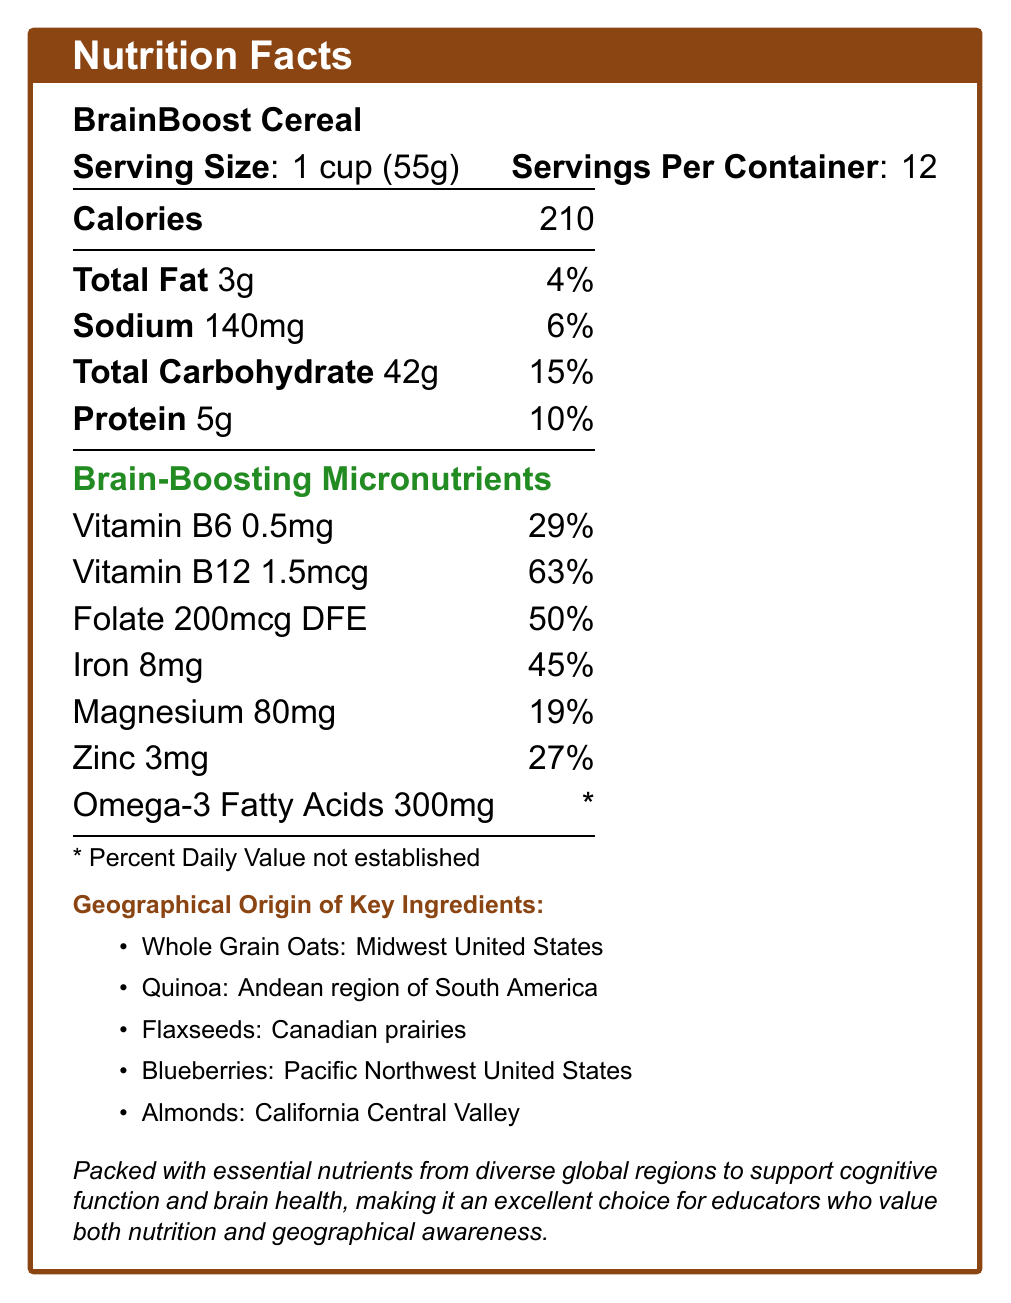What is the serving size of BrainBoost Cereal? The serving size is explicitly stated as "1 cup (55g)" in the document.
Answer: 1 cup (55g) How many servings are there per container of BrainBoost Cereal? The document states that there are 12 servings per container.
Answer: 12 How many calories are there in one serving of BrainBoost Cereal? The document clearly lists that each serving contains 210 calories.
Answer: 210 What percentage of the daily value of Vitamin B6 does one serving provide? According to the document, one serving provides 29% of the daily value for Vitamin B6.
Answer: 29% How much iron is in one serving of BrainBoost Cereal? The document specifies that one serving contains 8mg of iron.
Answer: 8mg Which micronutrient in BrainBoost Cereal has the highest percent daily value per serving? 
A. Vitamin B6
B. Vitamin B12
C. Folate
D. Iron 
E. Zinc The document shows that Vitamin B12 provides 63% of the daily value per serving, which is the highest percentage among the listed micronutrients.
Answer: B. Vitamin B12 From which region is the quinoa in BrainBoost Cereal sourced? 
1. Midwest United States
2. Andean region of South America
3. Canadian prairies
4. Pacific Northwest United States The geographical origin for quinoa is listed as "Andean region of South America" in the document.
Answer: 2. Andean region of South America Does BrainBoost Cereal contain more magnesium or zinc per serving? The document lists magnesium content as 80mg per serving and zinc content as 3mg per serving. Thus, BrainBoost Cereal contains more magnesium.
Answer: Magnesium Is there enough information in the document to determine the sugar content per serving of BrainBoost Cereal? The document does not mention the sugar content per serving.
Answer: No Summarize the key nutritional benefits of BrainBoost Cereal. The document emphasizes the cereal's brain-boosting micronutrients and the geographical origins of its key ingredients, positioning it as beneficial for cognitive health and an excellent choice for those valuing geographical awareness.
Answer: BrainBoost Cereal is rich in brain-boosting micronutrients such as Vitamin B6, Vitamin B12, folate, iron, magnesium, zinc, and omega-3 fatty acids. It also derives its ingredients from diverse global regions, making it a wholesome choice for cognitive function and brain health. What is the source region for the flaxseeds used in BrainBoost Cereal? The document lists that the flaxseeds are sourced from the Canadian prairies.
Answer: Canadian prairies How much protein does one serving of BrainBoost Cereal provide? The document specifies that one serving contains 5g of protein.
Answer: 5g What is the total carbohydrate content in one serving of BrainBoost Cereal? According to the document, one serving contains 42g of total carbohydrates.
Answer: 42g Is the percent daily value established for omega-3 fatty acids in BrainBoost Cereal? The document indicates that the percent daily value for omega-3 fatty acids is not established (marked with an asterisk).
Answer: No From which region are the blueberries in BrainBoost Cereal sourced? The document states that the blueberries are sourced from the Pacific Northwest United States.
Answer: Pacific Northwest United States What would be the calorie intake if a person consumes two servings of BrainBoost Cereal? One serving contains 210 calories, so consuming two servings would amount to 210 x 2 = 420 calories.
Answer: 420 Does the document provide the geographical origin of all ingredients used in BrainBoost Cereal? The document provides the geographical origin of key ingredients like whole grain oats, quinoa, flaxseeds, blueberries, and almonds, but it does not list all ingredients used.
Answer: No 